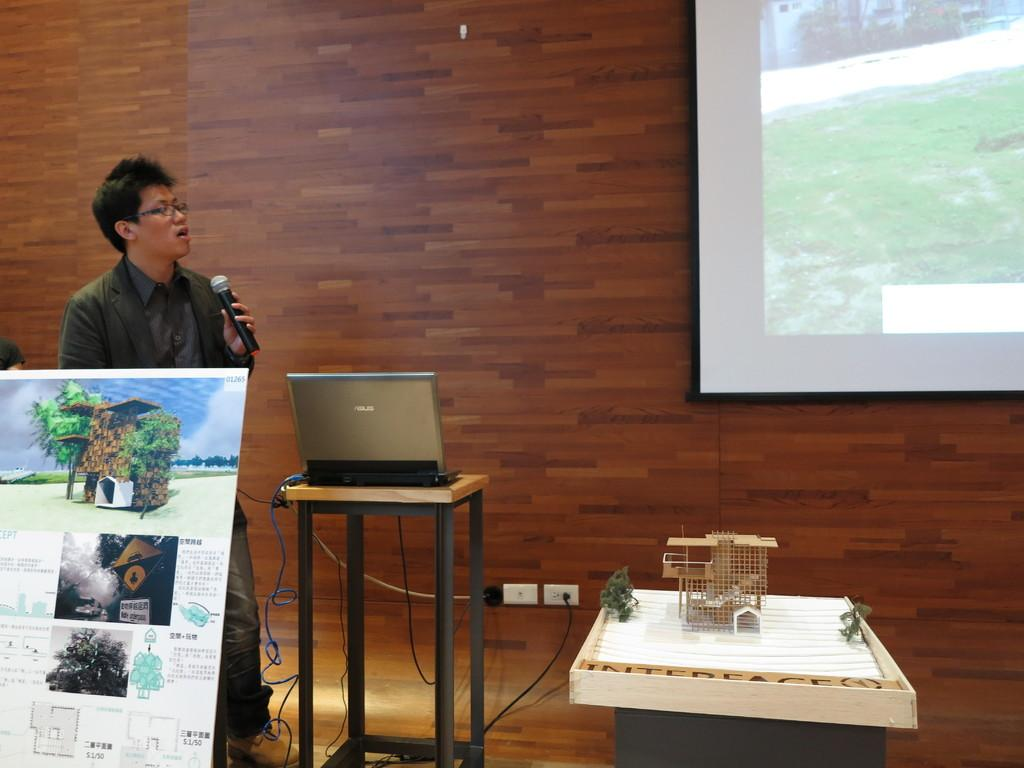What can be seen hanging on the wall in the image? There is a poster in the image. What piece of furniture is present in the image? There is a table in the image. What electronic device is on top of the table? A laptop is on top of the table. What is the guy in the image holding in his hand? The guy is holding a mic in his hand. What type of wall can be seen in the background of the image? There is a wooden wall in the background of the image. Can you see any shoes causing trouble in the image? There are no shoes or any indication of trouble in the image. Is there a hole in the wooden wall in the image? There is no hole visible in the wooden wall in the image. 